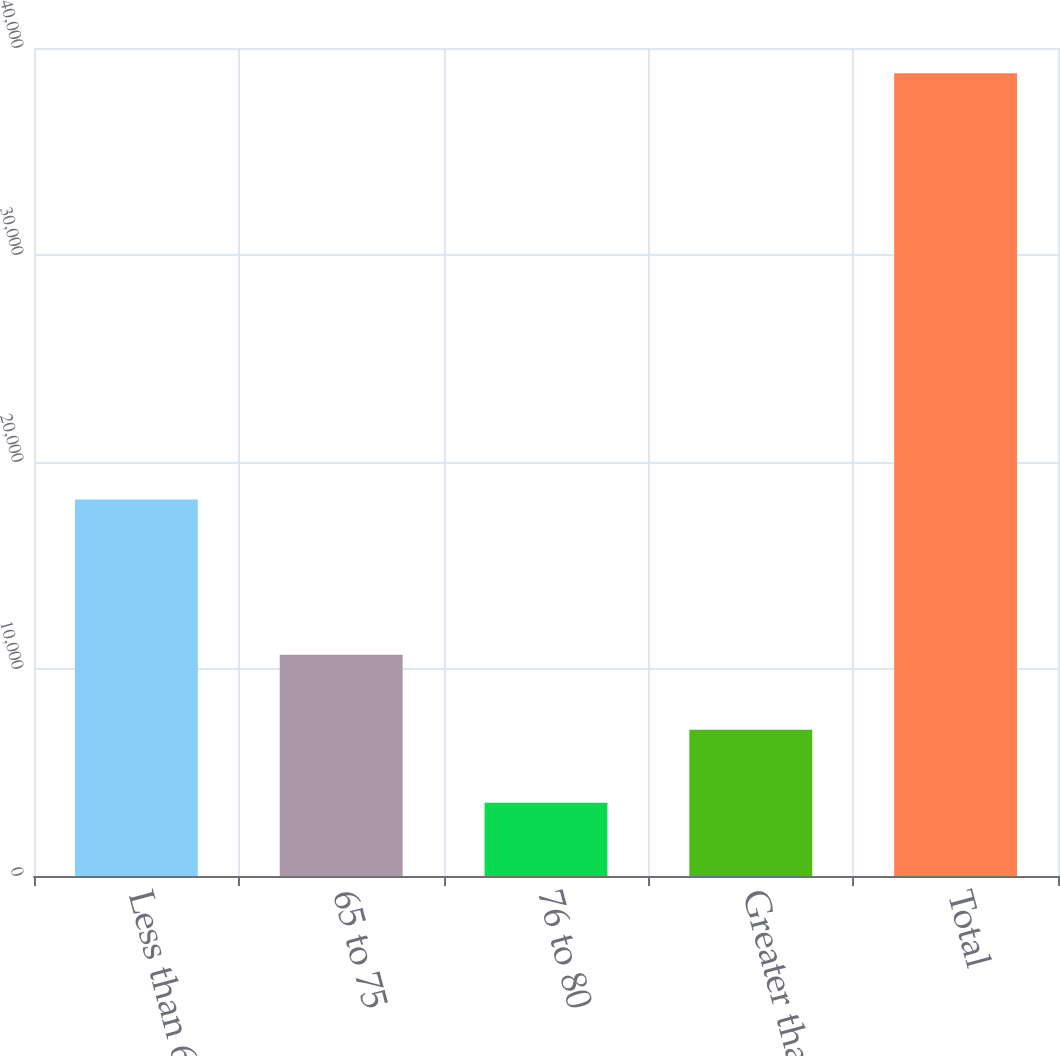Convert chart. <chart><loc_0><loc_0><loc_500><loc_500><bar_chart><fcel>Less than 65<fcel>65 to 75<fcel>76 to 80<fcel>Greater than 80<fcel>Total<nl><fcel>18183<fcel>10686<fcel>3536<fcel>7060.3<fcel>38779<nl></chart> 